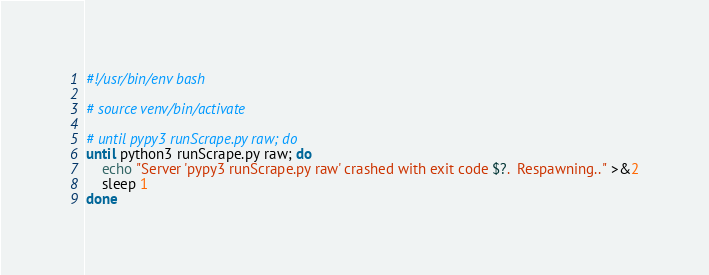<code> <loc_0><loc_0><loc_500><loc_500><_Bash_>#!/usr/bin/env bash

# source venv/bin/activate

# until pypy3 runScrape.py raw; do
until python3 runScrape.py raw; do
    echo "Server 'pypy3 runScrape.py raw' crashed with exit code $?.  Respawning.." >&2
    sleep 1
done</code> 